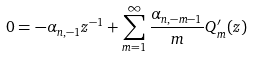Convert formula to latex. <formula><loc_0><loc_0><loc_500><loc_500>0 = - \alpha _ { n , - 1 } z ^ { - 1 } + \sum _ { m = 1 } ^ { \infty } \frac { \alpha _ { n , - m - 1 } } { m } Q _ { m } ^ { \prime } ( z )</formula> 